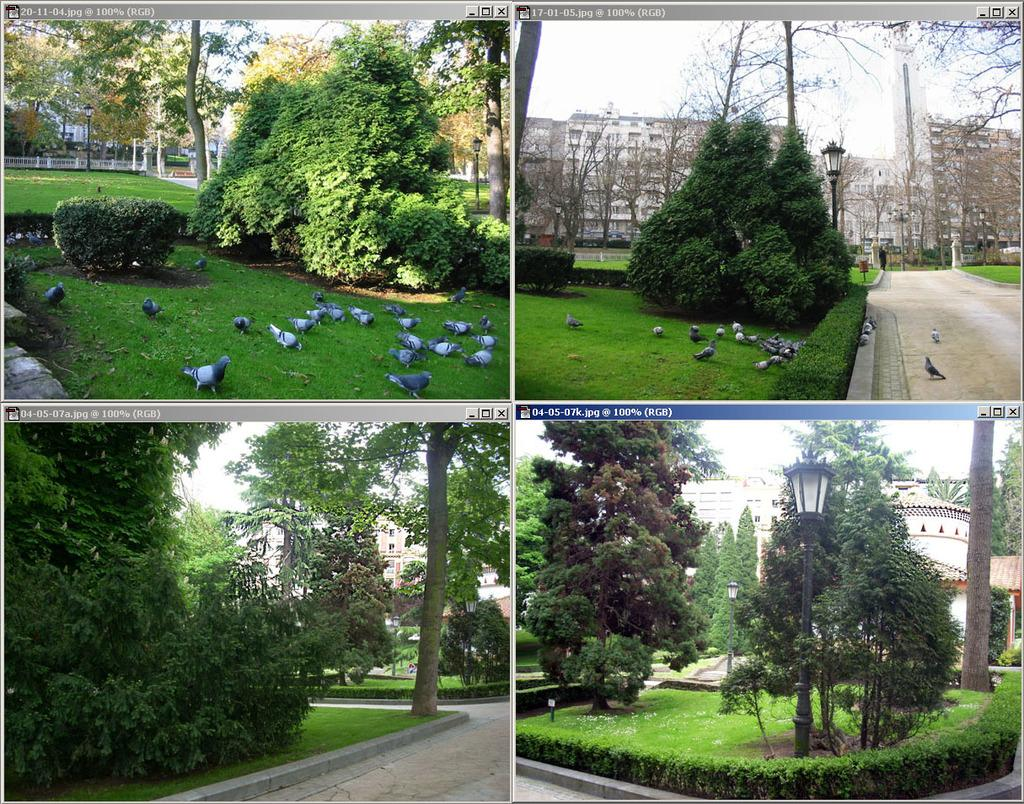What type of institution is depicted in the image? The image contains a college. What can be seen in the image besides the college? There is greenery in the image. Are there any animals visible in the image? Yes, there are pigeons on the grassland in two images. What type of health care is being provided to the pigeons in the image? There is no indication in the image that any health care is being provided to the pigeons. 